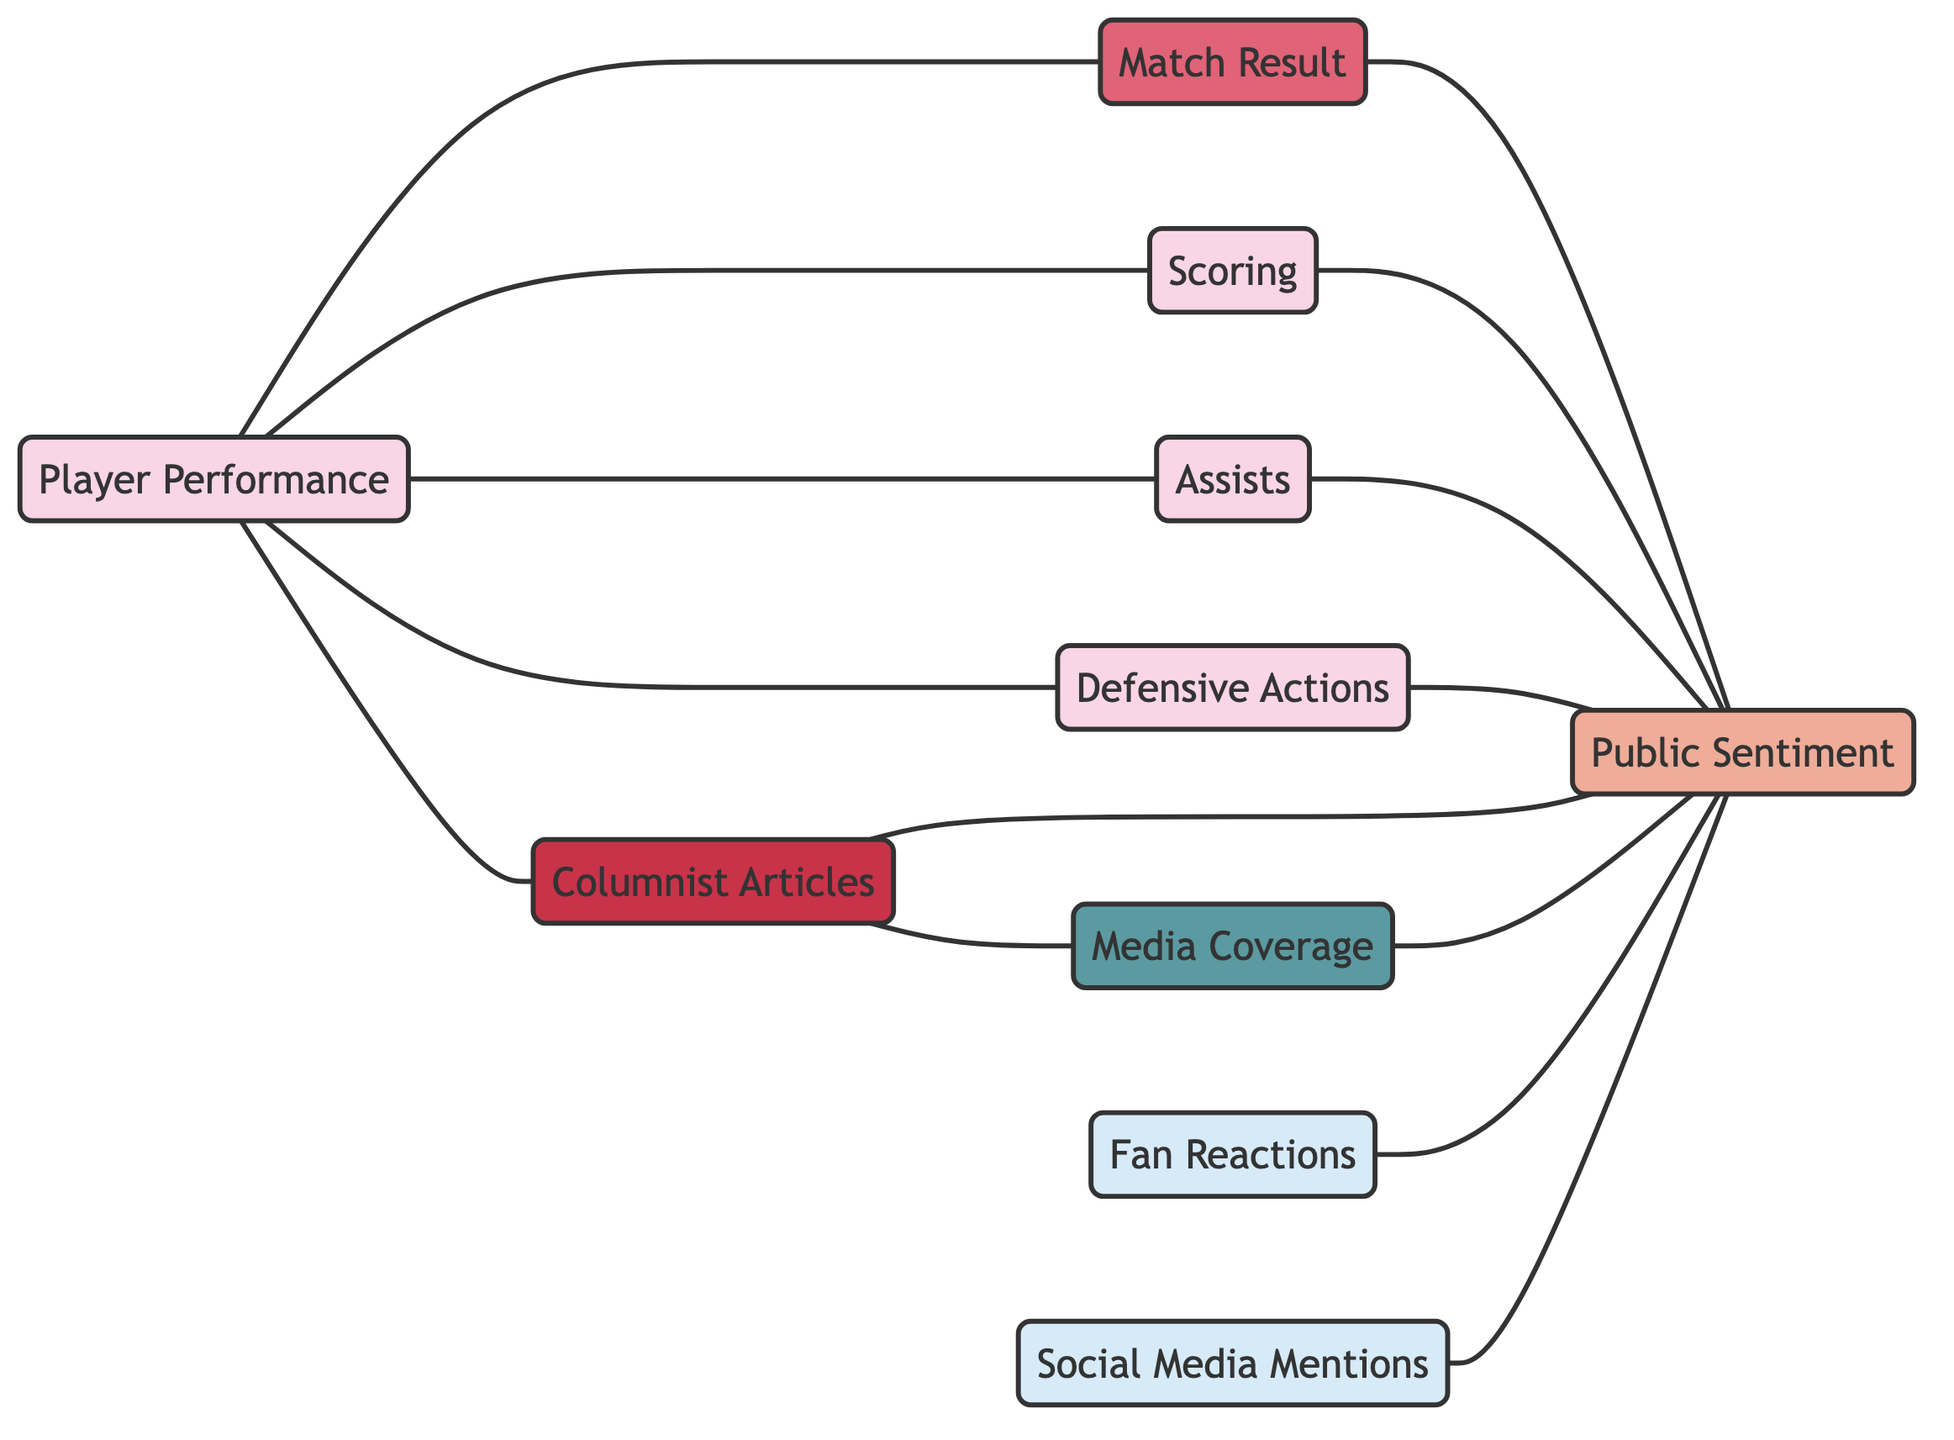what are the total number of nodes in the diagram? The diagram lists a total of ten distinct nodes. Each node represents a different concept related to football performance and public sentiment.
Answer: 10 what is the direct relationship between player performance and match result? The edge between "Player Performance" and "Match Result" indicates a direct relationship, meaning player performance can significantly influence the outcome of a match.
Answer: Influence how many edges connect public sentiment to other nodes? Public sentiment has six edges connecting it to "Match Result," "Scoring," "Assists," "Defensive Actions," "Columnist Articles," "Fan Reactions," and "Social Media Mentions," totaling six connections.
Answer: 6 which node serves as a precursor for media coverage? The "Columnist Articles" node has a direct edge connecting it to "Media Coverage," indicating that columnist articles lead to media coverage.
Answer: Columnist Articles what is the connection type between assists and public sentiment? The connection between "Assists" and "Public Sentiment" is established through an undirected edge, which signifies that assists have a direct impact on public sentiment.
Answer: Undirected does scoring impact public sentiment directly? Yes, "Scoring" directly influences "Public Sentiment," as indicated by the edge connecting the two nodes in the diagram.
Answer: Yes which node has the most connections with public sentiment? The "Columnist Articles" node has connections to "Media Coverage" and "Public Sentiment," making it a central node influencing public perception.
Answer: Columnist Articles what type of interactions are represented by the edges in this diagram? The edges represent undirected relationships, indicating bi-directional influences between the linked nodes pertaining to match performances and public sentiment.
Answer: Undirected relationships what is the primary subject matter of the diagram? The primary subject matter of the diagram focuses on the connections between match performances and public sentiment as expressed in columnist articles.
Answer: Links Between Match Performances and Public Sentiment 